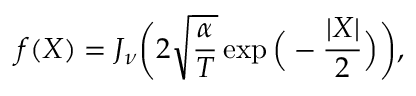Convert formula to latex. <formula><loc_0><loc_0><loc_500><loc_500>f ( X ) = J _ { \nu } \left ( 2 \sqrt { \frac { \alpha } { T } } \exp \left ( - \frac { | X | } { 2 } \right ) \right ) ,</formula> 